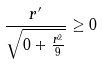<formula> <loc_0><loc_0><loc_500><loc_500>\frac { r ^ { \prime } } { \sqrt { 0 + \frac { r ^ { 2 } } { 9 } } } \geq 0</formula> 